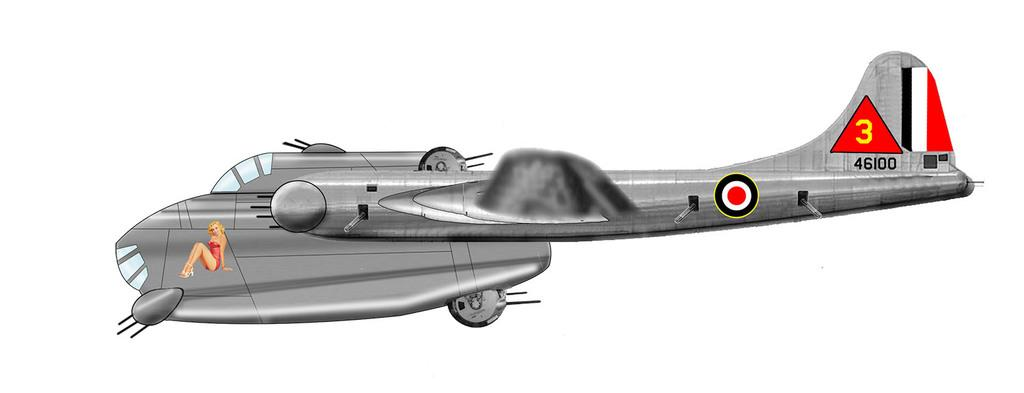Provide a one-sentence caption for the provided image. Sketch of a plane with the numbers 46100 near the tail. 